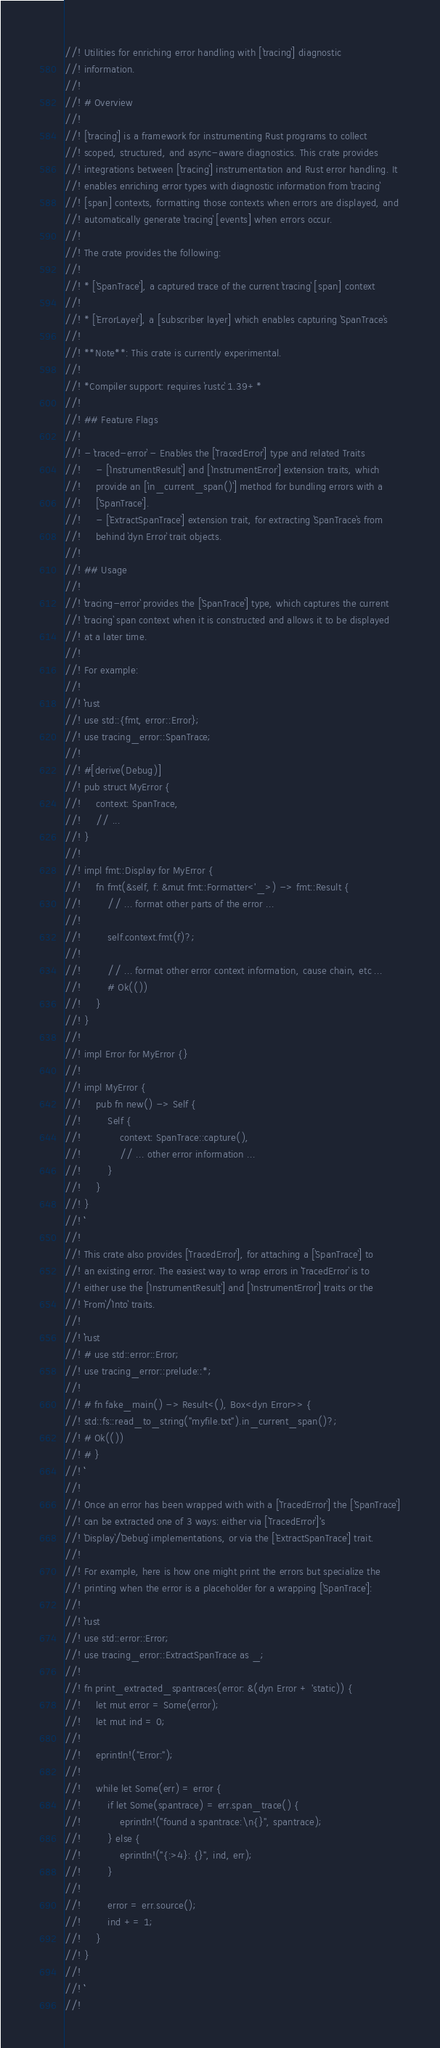Convert code to text. <code><loc_0><loc_0><loc_500><loc_500><_Rust_>//! Utilities for enriching error handling with [`tracing`] diagnostic
//! information.
//!
//! # Overview
//!
//! [`tracing`] is a framework for instrumenting Rust programs to collect
//! scoped, structured, and async-aware diagnostics. This crate provides
//! integrations between [`tracing`] instrumentation and Rust error handling. It
//! enables enriching error types with diagnostic information from `tracing`
//! [span] contexts, formatting those contexts when errors are displayed, and
//! automatically generate `tracing` [events] when errors occur.
//!
//! The crate provides the following:
//!
//! * [`SpanTrace`], a captured trace of the current `tracing` [span] context
//!
//! * [`ErrorLayer`], a [subscriber layer] which enables capturing `SpanTrace`s
//!
//! **Note**: This crate is currently experimental.
//!
//! *Compiler support: requires `rustc` 1.39+*
//!
//! ## Feature Flags
//!
//! - `traced-error` - Enables the [`TracedError`] type and related Traits
//!     - [`InstrumentResult`] and [`InstrumentError`] extension traits, which
//!     provide an [`in_current_span()`] method for bundling errors with a
//!     [`SpanTrace`].
//!     - [`ExtractSpanTrace`] extension trait, for extracting `SpanTrace`s from
//!     behind `dyn Error` trait objects.
//!
//! ## Usage
//!
//! `tracing-error` provides the [`SpanTrace`] type, which captures the current
//! `tracing` span context when it is constructed and allows it to be displayed
//! at a later time.
//!
//! For example:
//!
//! ```rust
//! use std::{fmt, error::Error};
//! use tracing_error::SpanTrace;
//!
//! #[derive(Debug)]
//! pub struct MyError {
//!     context: SpanTrace,
//!     // ...
//! }
//!
//! impl fmt::Display for MyError {
//!     fn fmt(&self, f: &mut fmt::Formatter<'_>) -> fmt::Result {
//!         // ... format other parts of the error ...
//!
//!         self.context.fmt(f)?;
//!
//!         // ... format other error context information, cause chain, etc ...
//!         # Ok(())
//!     }
//! }
//!
//! impl Error for MyError {}
//!
//! impl MyError {
//!     pub fn new() -> Self {
//!         Self {
//!             context: SpanTrace::capture(),
//!             // ... other error information ...
//!         }
//!     }
//! }
//! ```
//!
//! This crate also provides [`TracedError`], for attaching a [`SpanTrace`] to
//! an existing error. The easiest way to wrap errors in `TracedError` is to
//! either use the [`InstrumentResult`] and [`InstrumentError`] traits or the
//! `From`/`Into` traits.
//!
//! ```rust
//! # use std::error::Error;
//! use tracing_error::prelude::*;
//!
//! # fn fake_main() -> Result<(), Box<dyn Error>> {
//! std::fs::read_to_string("myfile.txt").in_current_span()?;
//! # Ok(())
//! # }
//! ```
//!
//! Once an error has been wrapped with with a [`TracedError`] the [`SpanTrace`]
//! can be extracted one of 3 ways: either via [`TracedError`]'s
//! `Display`/`Debug` implementations, or via the [`ExtractSpanTrace`] trait.
//!
//! For example, here is how one might print the errors but specialize the
//! printing when the error is a placeholder for a wrapping [`SpanTrace`]:
//!
//! ```rust
//! use std::error::Error;
//! use tracing_error::ExtractSpanTrace as _;
//!
//! fn print_extracted_spantraces(error: &(dyn Error + 'static)) {
//!     let mut error = Some(error);
//!     let mut ind = 0;
//!
//!     eprintln!("Error:");
//!
//!     while let Some(err) = error {
//!         if let Some(spantrace) = err.span_trace() {
//!             eprintln!("found a spantrace:\n{}", spantrace);
//!         } else {
//!             eprintln!("{:>4}: {}", ind, err);
//!         }
//!
//!         error = err.source();
//!         ind += 1;
//!     }
//! }
//!
//! ```
//!</code> 